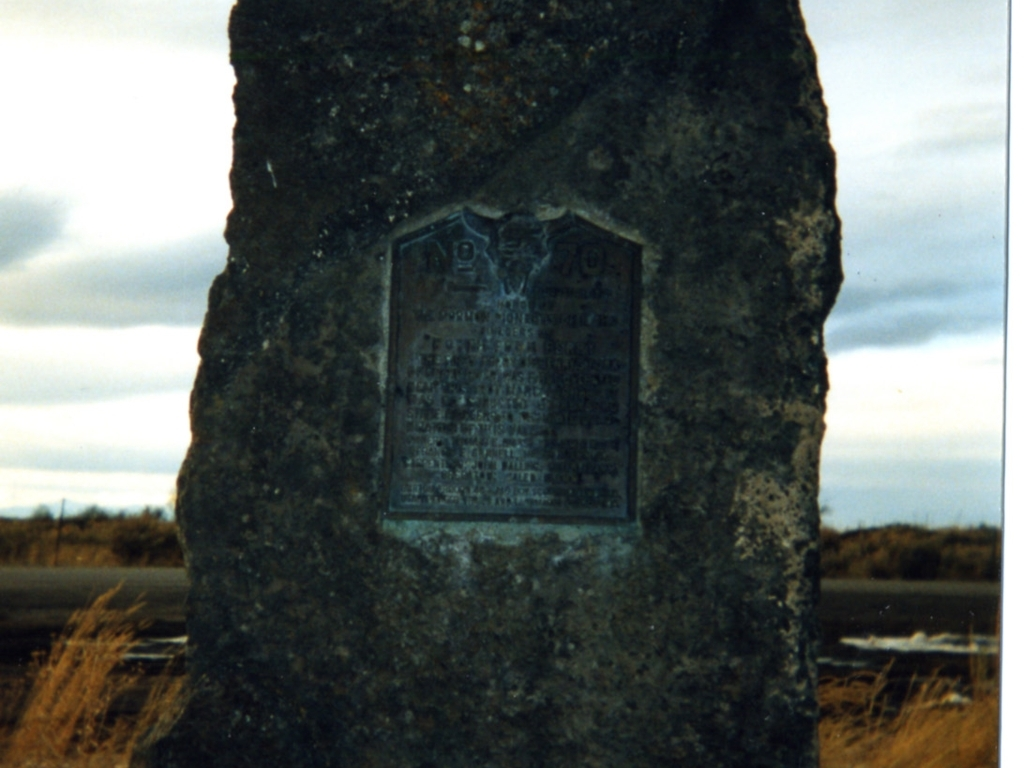What suggestions do you have for preserving this monument for future generations? To preserve this monument, measures should be taken to protect the stone and metal plaque from the elements. This could include applying a protective coating to the stone, ensuring drainage around the base to prevent water damage, and possibly adding an informational sign to educate visitors about the significance of the monument. Regular maintenance to clean off any biological growth or deposited dirt would also be beneficial. 